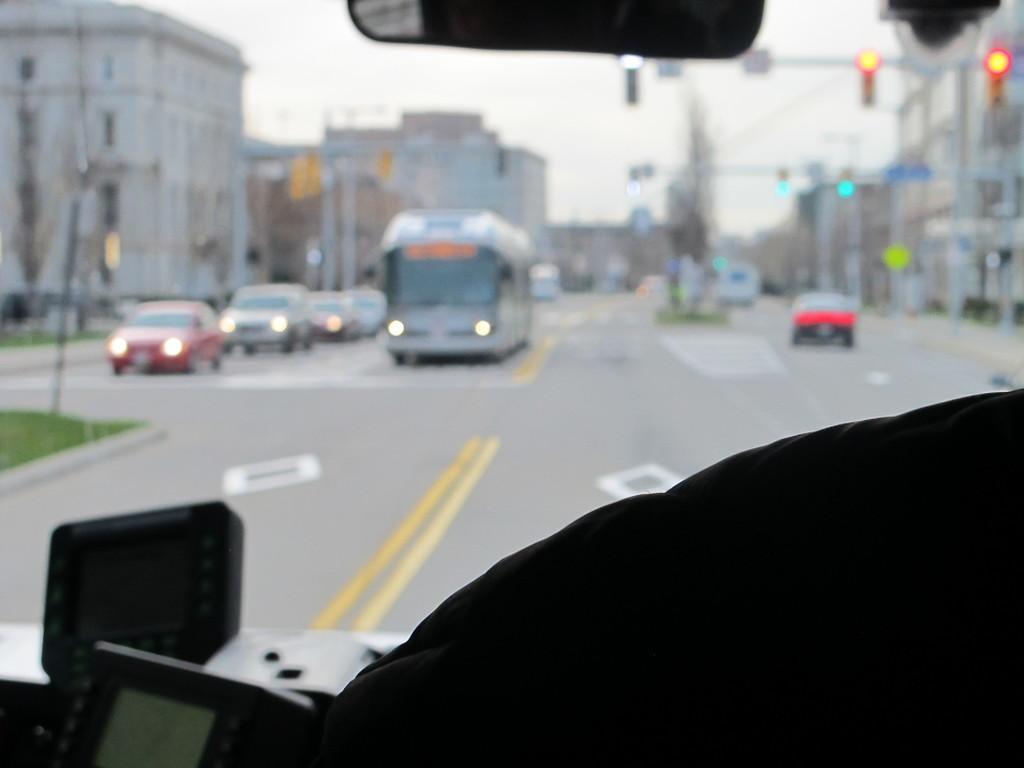Please provide a concise description of this image. In this image I can see fleets of vehicles on the road, light poles, sign boards, buildings, grass, fence, trees, windows and the sky. This image is an inside view of a vehicle. 